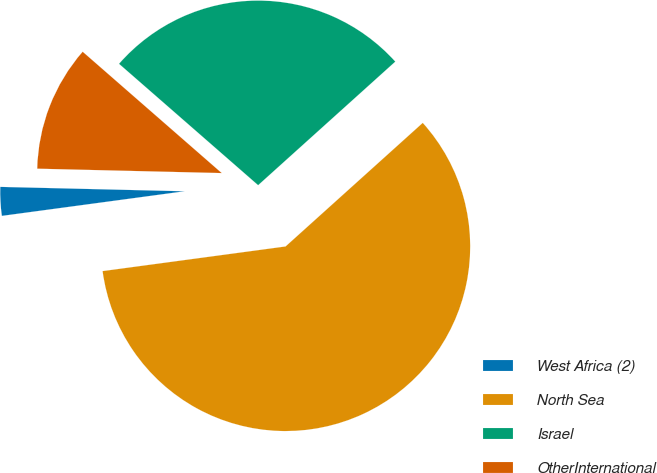Convert chart. <chart><loc_0><loc_0><loc_500><loc_500><pie_chart><fcel>West Africa (2)<fcel>North Sea<fcel>Israel<fcel>OtherInternational<nl><fcel>2.51%<fcel>59.54%<fcel>26.91%<fcel>11.04%<nl></chart> 